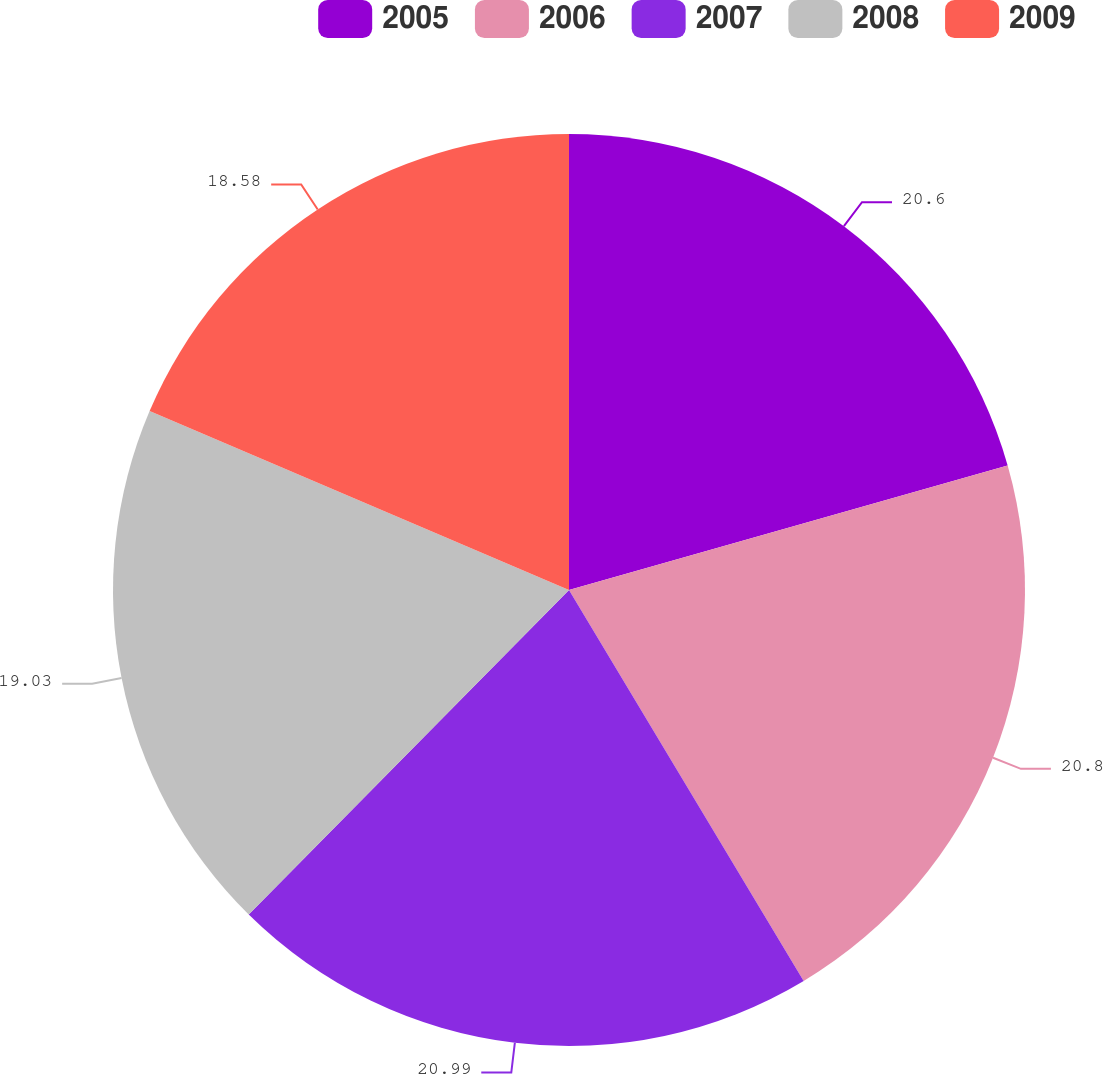Convert chart to OTSL. <chart><loc_0><loc_0><loc_500><loc_500><pie_chart><fcel>2005<fcel>2006<fcel>2007<fcel>2008<fcel>2009<nl><fcel>20.6%<fcel>20.8%<fcel>21.0%<fcel>19.03%<fcel>18.58%<nl></chart> 